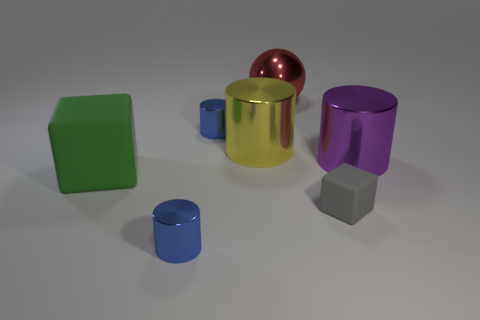Are there any cylinders that have the same size as the red metal sphere?
Your answer should be compact. Yes. What number of large blocks are there?
Give a very brief answer. 1. There is a large green rubber object; what number of tiny blue things are in front of it?
Your answer should be compact. 1. Is the material of the green thing the same as the big purple object?
Make the answer very short. No. What number of metallic objects are both to the left of the small cube and in front of the metal ball?
Keep it short and to the point. 3. How many other things are the same color as the small block?
Provide a short and direct response. 0. What number of yellow things are spheres or metallic things?
Offer a very short reply. 1. The gray block is what size?
Make the answer very short. Small. What number of metal objects are either small brown cylinders or big red objects?
Keep it short and to the point. 1. Are there fewer big yellow cylinders than blue metal blocks?
Keep it short and to the point. No. 